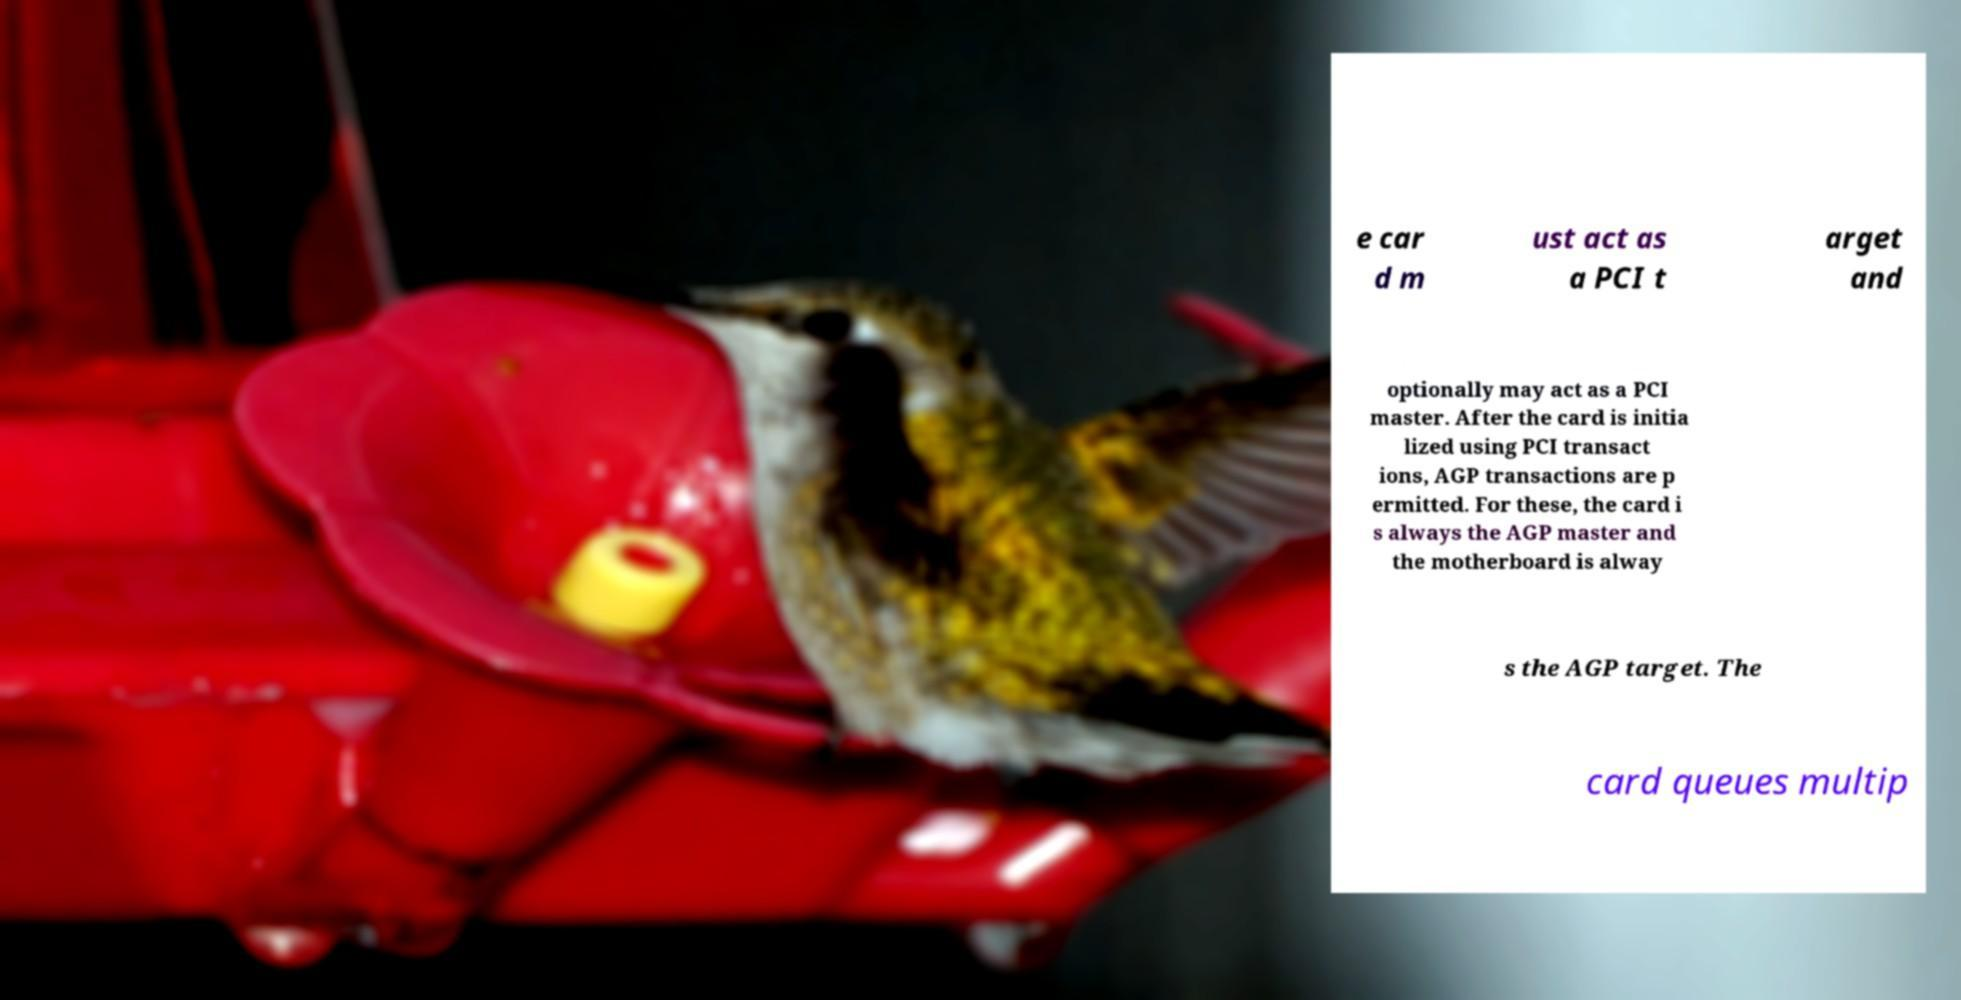Could you assist in decoding the text presented in this image and type it out clearly? e car d m ust act as a PCI t arget and optionally may act as a PCI master. After the card is initia lized using PCI transact ions, AGP transactions are p ermitted. For these, the card i s always the AGP master and the motherboard is alway s the AGP target. The card queues multip 